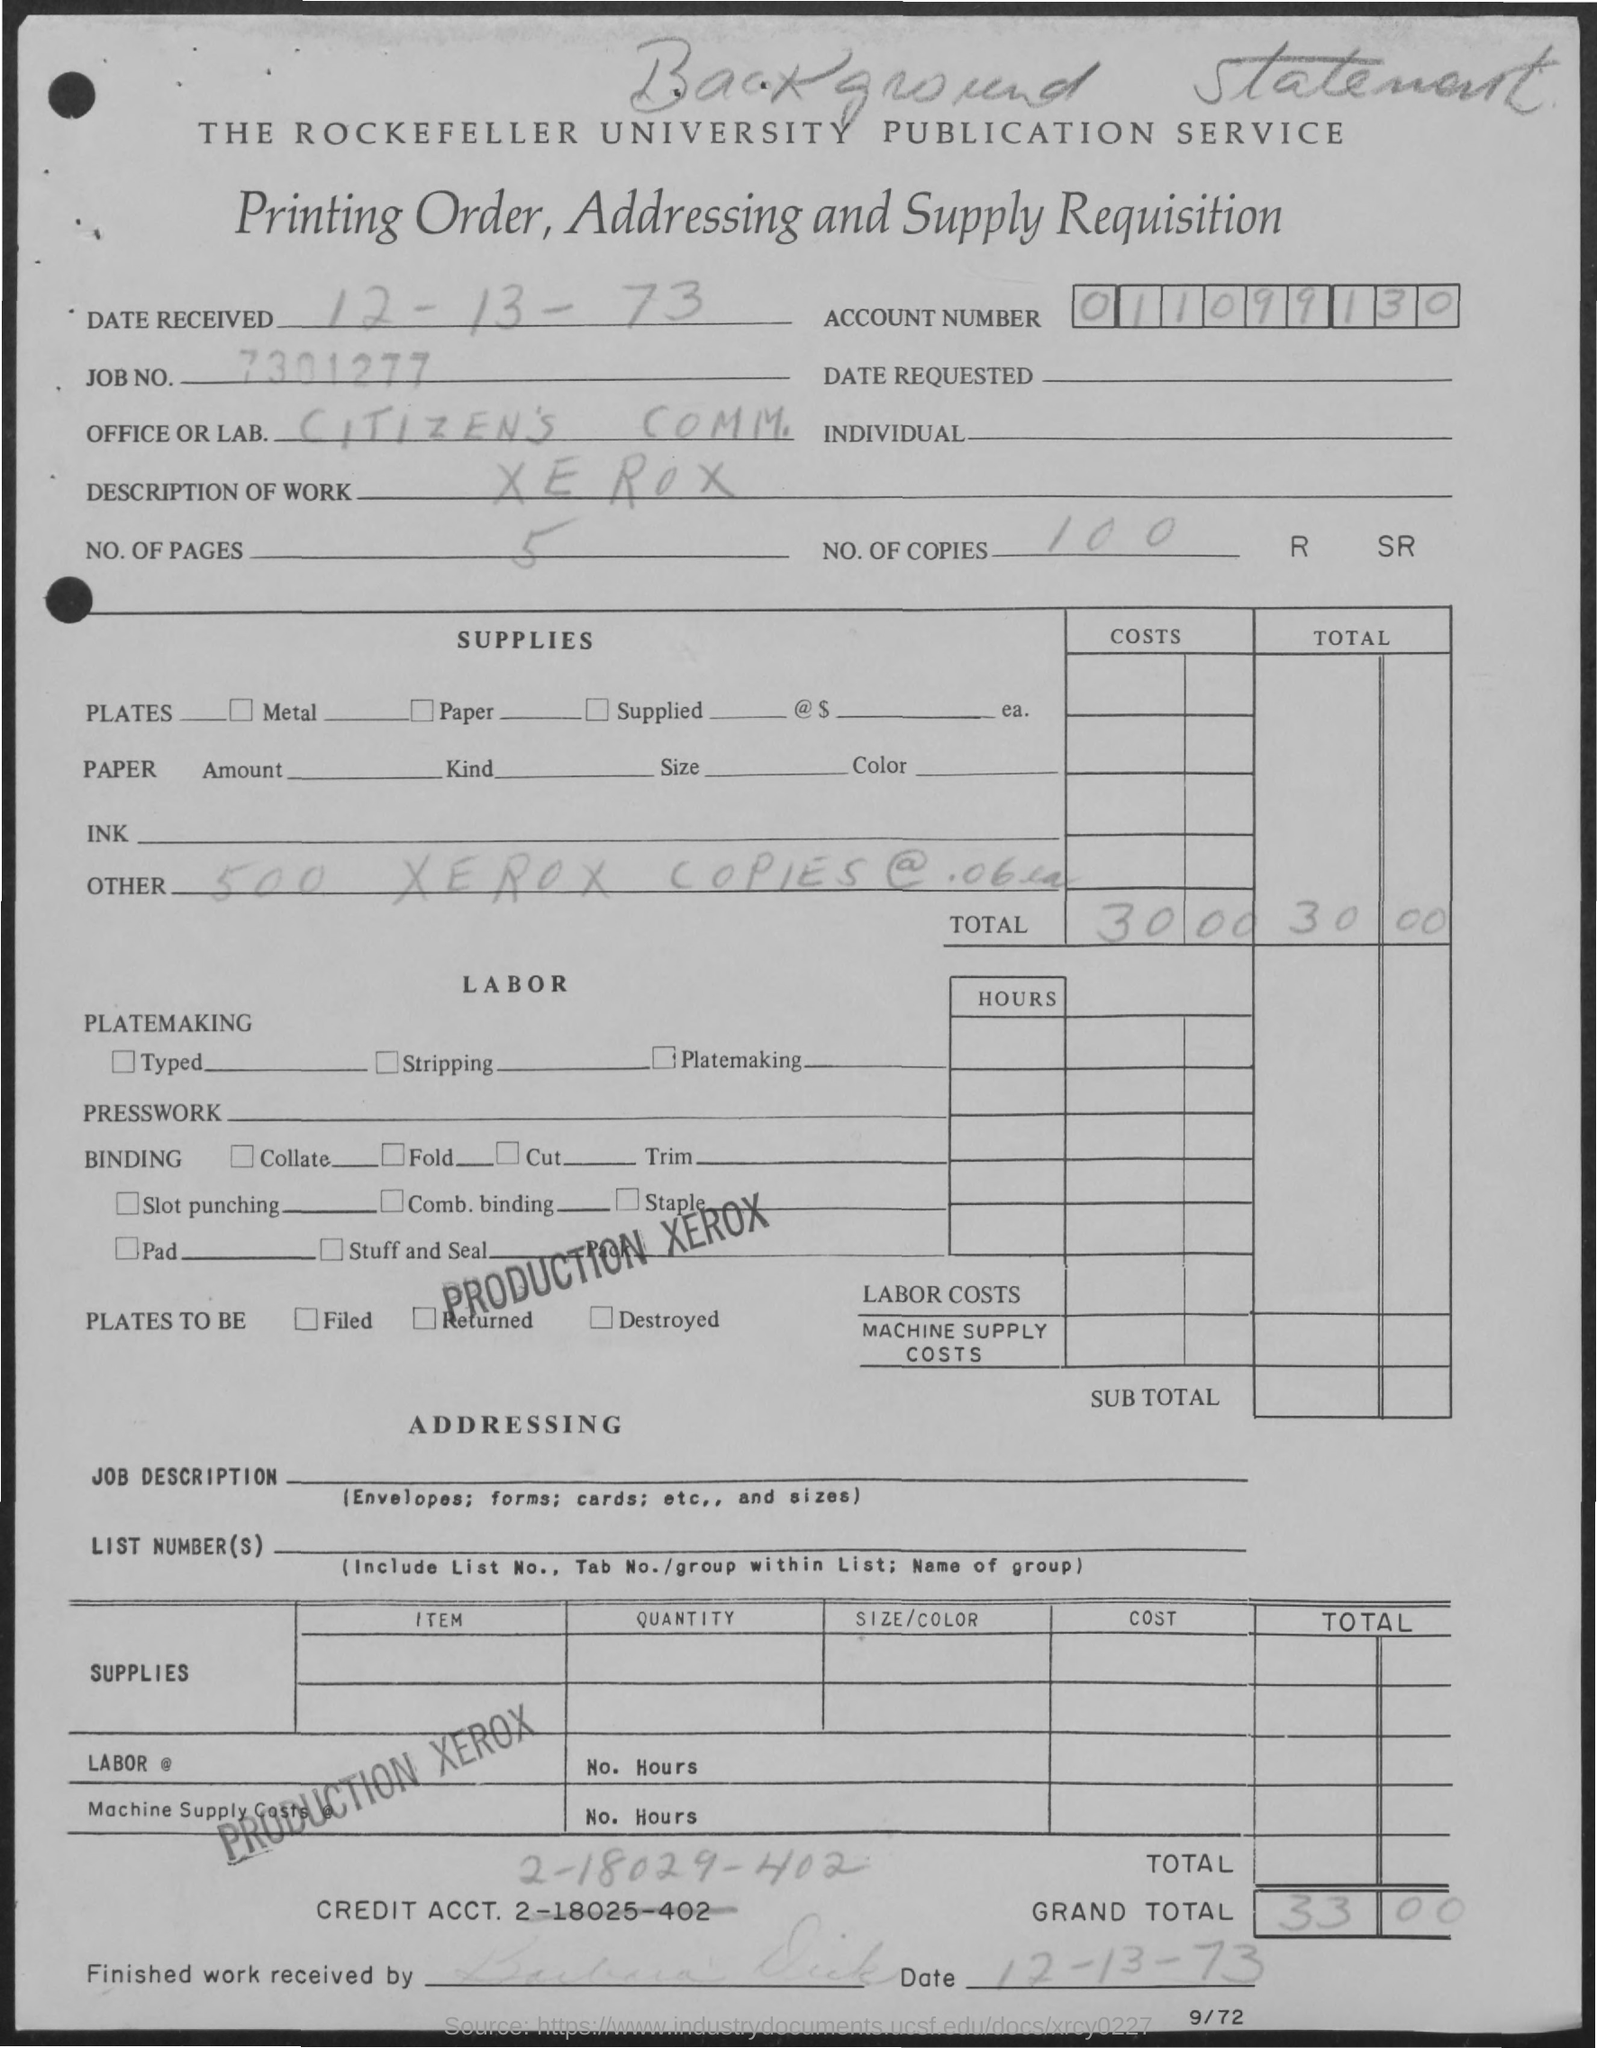When is the Date Received?
Your answer should be very brief. 12-13-73. What is Job No.?
Keep it short and to the point. 7301277. Which is the Office or Lab?
Give a very brief answer. Citizen's comm. What is the Description of work?
Your response must be concise. Xerox. What is the No. of pages?
Ensure brevity in your answer.  5. What is the Account Number?
Give a very brief answer. 0-1-1-0-9-9-1-3-0. What is the No. of copies?
Your answer should be very brief. 100. What is the Total?
Offer a very short reply. 30.00. What is the Grand Total?
Offer a very short reply. 33.00. 